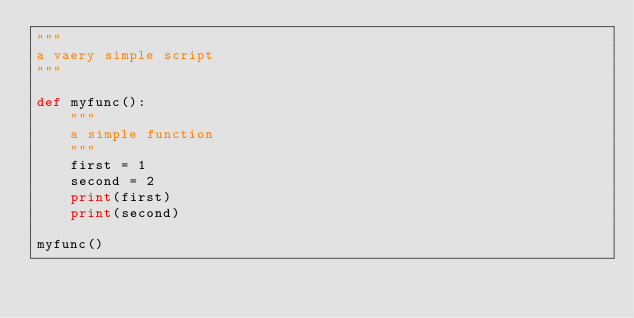<code> <loc_0><loc_0><loc_500><loc_500><_Python_>"""
a vaery simple script
"""

def myfunc():
    """
    a simple function
    """
    first = 1
    second = 2
    print(first)
    print(second)

myfunc()
</code> 